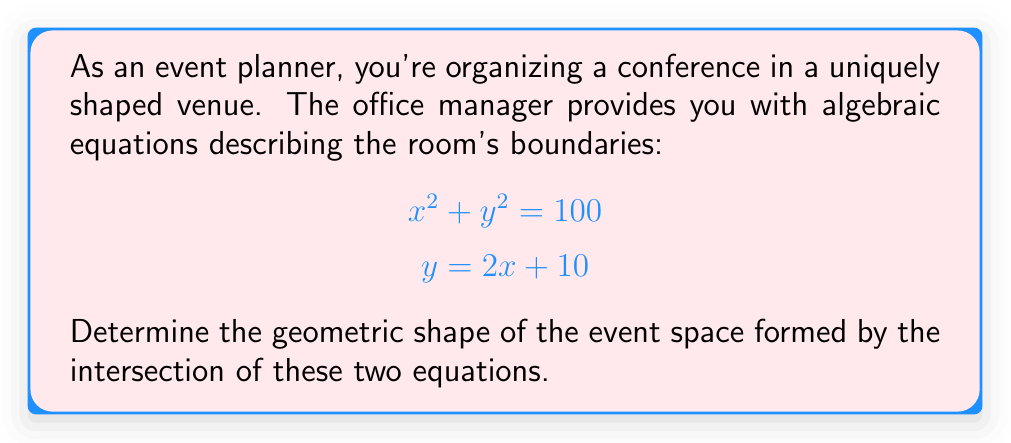Solve this math problem. Let's approach this step-by-step:

1) The first equation, $x^2 + y^2 = 100$, represents a circle with radius 10 centered at the origin (0,0).

2) The second equation, $y = 2x + 10$, represents a straight line with a slope of 2 and y-intercept of 10.

3) To find the intersection, we need to solve these equations simultaneously:

   Substitute $y = 2x + 10$ into $x^2 + y^2 = 100$:
   
   $$x^2 + (2x + 10)^2 = 100$$

4) Expand this equation:

   $$x^2 + 4x^2 + 40x + 100 = 100$$
   $$5x^2 + 40x = 0$$

5) Factor out x:

   $$x(5x + 40) = 0$$

6) Solve for x:

   $x = 0$ or $x = -8$

7) Substitute these x-values back into $y = 2x + 10$ to get the corresponding y-values:

   When $x = 0$, $y = 10$
   When $x = -8$, $y = -6$

8) So, the line intersects the circle at two points: (0, 10) and (-8, -6).

9) The portion of the circle between these two points, combined with the line segment connecting them, forms the boundary of our event space.

[asy]
import geometry;

size(200);
draw(circle((0,0), 10));
draw((-10,-10)--(5,20), blue);
draw((0,10)--(-8,-6), red);
dot((0,10));
dot((-8,-6));
label("(0,10)", (0,10), NE);
label("(-8,-6)", (-8,-6), SW);
[/asy]
Answer: Circular segment 